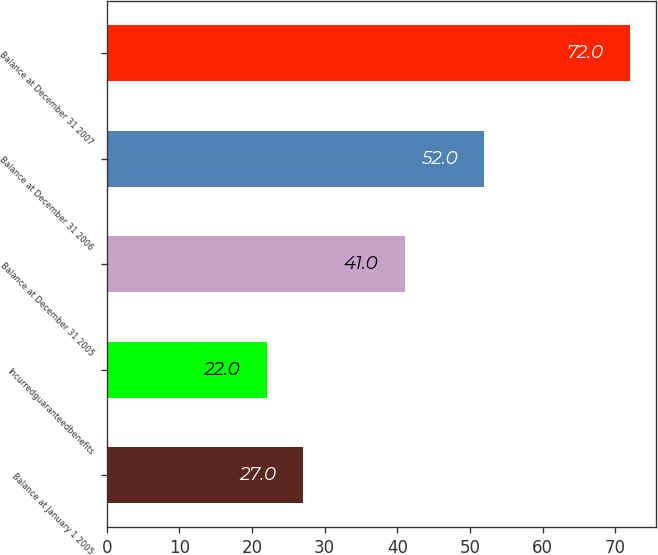Convert chart to OTSL. <chart><loc_0><loc_0><loc_500><loc_500><bar_chart><fcel>Balance at January 1 2005<fcel>Incurredguaranteedbenefits<fcel>Balance at December 31 2005<fcel>Balance at December 31 2006<fcel>Balance at December 31 2007<nl><fcel>27<fcel>22<fcel>41<fcel>52<fcel>72<nl></chart> 